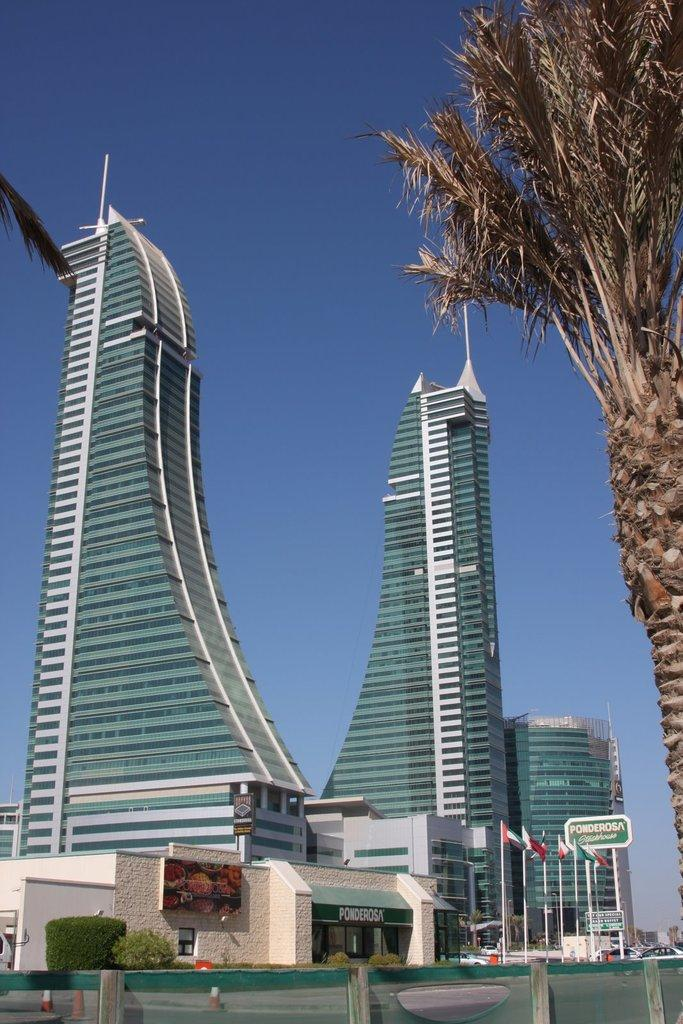What type of structures can be seen in the image? There are buildings in the image. What else can be seen in the image besides buildings? There are trees, flags, and boards visible in the image. What are the objects in the image used for? The objects in the image are not specified, but they could serve various purposes. What is visible in the background of the image? The sky is visible in the background of the image. How many flies can be seen on the boards in the image? There are no flies present in the image; it only features buildings, trees, flags, and boards. 